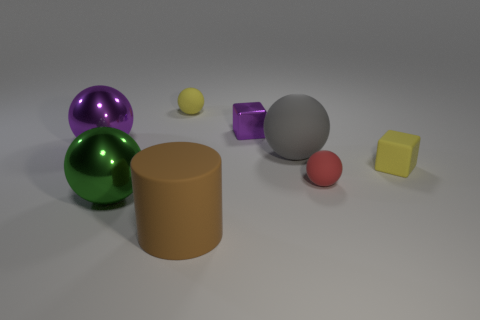Are there more small red matte objects behind the small yellow matte ball than rubber objects that are behind the small purple cube?
Your answer should be very brief. No. Is there a yellow cube that has the same size as the yellow rubber sphere?
Provide a succinct answer. Yes. There is a shiny ball behind the yellow object to the right of the small yellow thing to the left of the small red matte thing; what is its size?
Your response must be concise. Large. The big matte ball is what color?
Your answer should be very brief. Gray. Is the number of matte spheres that are behind the red thing greater than the number of big purple metal balls?
Your answer should be very brief. Yes. There is a large gray matte sphere; what number of things are in front of it?
Make the answer very short. 4. What shape is the small thing that is the same color as the tiny rubber block?
Give a very brief answer. Sphere. Is there a large purple object that is in front of the small matte sphere behind the large ball that is on the right side of the yellow rubber ball?
Ensure brevity in your answer.  Yes. Do the green sphere and the metallic block have the same size?
Make the answer very short. No. Are there the same number of big brown objects that are left of the large cylinder and tiny matte spheres that are right of the big matte ball?
Provide a succinct answer. No. 